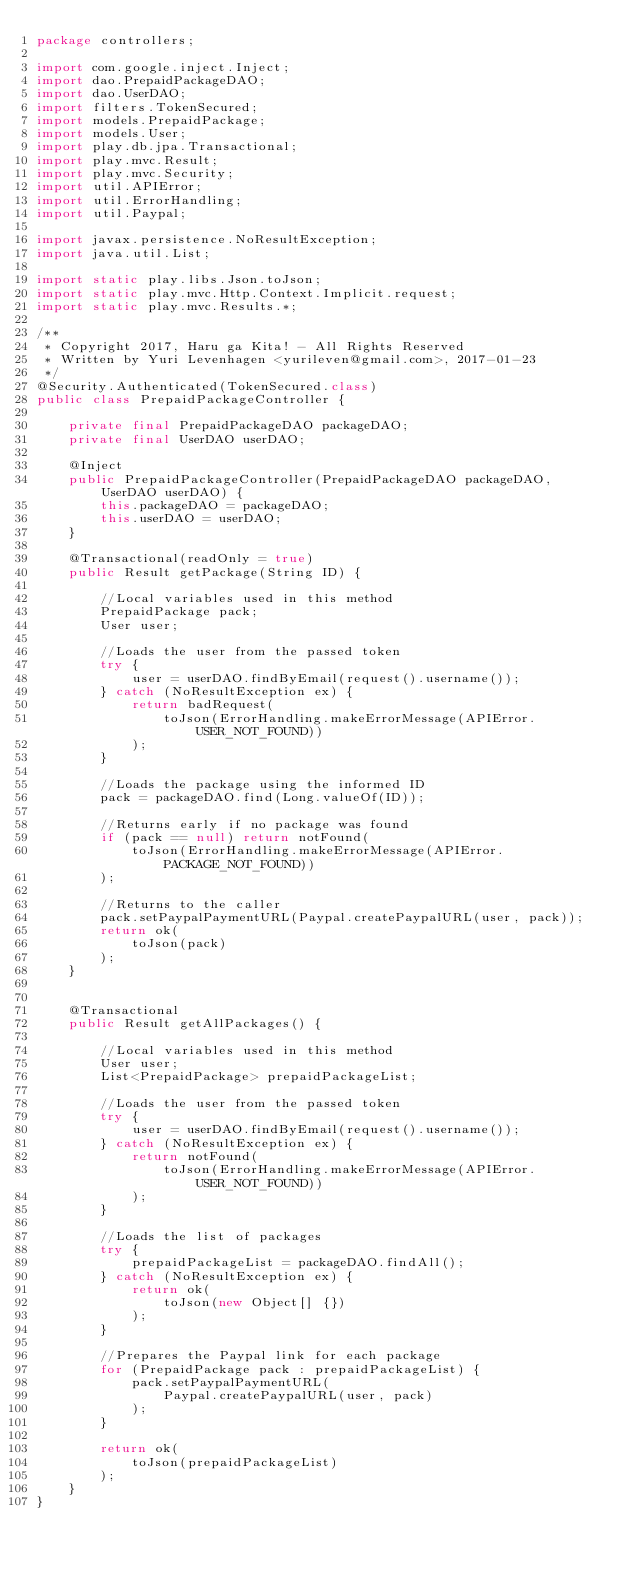Convert code to text. <code><loc_0><loc_0><loc_500><loc_500><_Java_>package controllers;

import com.google.inject.Inject;
import dao.PrepaidPackageDAO;
import dao.UserDAO;
import filters.TokenSecured;
import models.PrepaidPackage;
import models.User;
import play.db.jpa.Transactional;
import play.mvc.Result;
import play.mvc.Security;
import util.APIError;
import util.ErrorHandling;
import util.Paypal;

import javax.persistence.NoResultException;
import java.util.List;

import static play.libs.Json.toJson;
import static play.mvc.Http.Context.Implicit.request;
import static play.mvc.Results.*;

/**
 * Copyright 2017, Haru ga Kita! - All Rights Reserved
 * Written by Yuri Levenhagen <yurileven@gmail.com>, 2017-01-23
 */
@Security.Authenticated(TokenSecured.class)
public class PrepaidPackageController {

    private final PrepaidPackageDAO packageDAO;
    private final UserDAO userDAO;

    @Inject
    public PrepaidPackageController(PrepaidPackageDAO packageDAO, UserDAO userDAO) {
        this.packageDAO = packageDAO;
        this.userDAO = userDAO;
    }

    @Transactional(readOnly = true)
    public Result getPackage(String ID) {

        //Local variables used in this method
        PrepaidPackage pack;
        User user;

        //Loads the user from the passed token
        try {
            user = userDAO.findByEmail(request().username());
        } catch (NoResultException ex) {
            return badRequest(
                toJson(ErrorHandling.makeErrorMessage(APIError.USER_NOT_FOUND))
            );
        }

        //Loads the package using the informed ID
        pack = packageDAO.find(Long.valueOf(ID));

        //Returns early if no package was found
        if (pack == null) return notFound(
            toJson(ErrorHandling.makeErrorMessage(APIError.PACKAGE_NOT_FOUND))
        );

        //Returns to the caller
        pack.setPaypalPaymentURL(Paypal.createPaypalURL(user, pack));
        return ok(
            toJson(pack)
        );
    }


    @Transactional
    public Result getAllPackages() {

        //Local variables used in this method
        User user;
        List<PrepaidPackage> prepaidPackageList;

        //Loads the user from the passed token
        try {
            user = userDAO.findByEmail(request().username());
        } catch (NoResultException ex) {
            return notFound(
                toJson(ErrorHandling.makeErrorMessage(APIError.USER_NOT_FOUND))
            );
        }

        //Loads the list of packages
        try {
            prepaidPackageList = packageDAO.findAll();
        } catch (NoResultException ex) {
            return ok(
                toJson(new Object[] {})
            );
        }

        //Prepares the Paypal link for each package
        for (PrepaidPackage pack : prepaidPackageList) {
            pack.setPaypalPaymentURL(
                Paypal.createPaypalURL(user, pack)
            );
        }

        return ok(
            toJson(prepaidPackageList)
        );
    }
}
</code> 